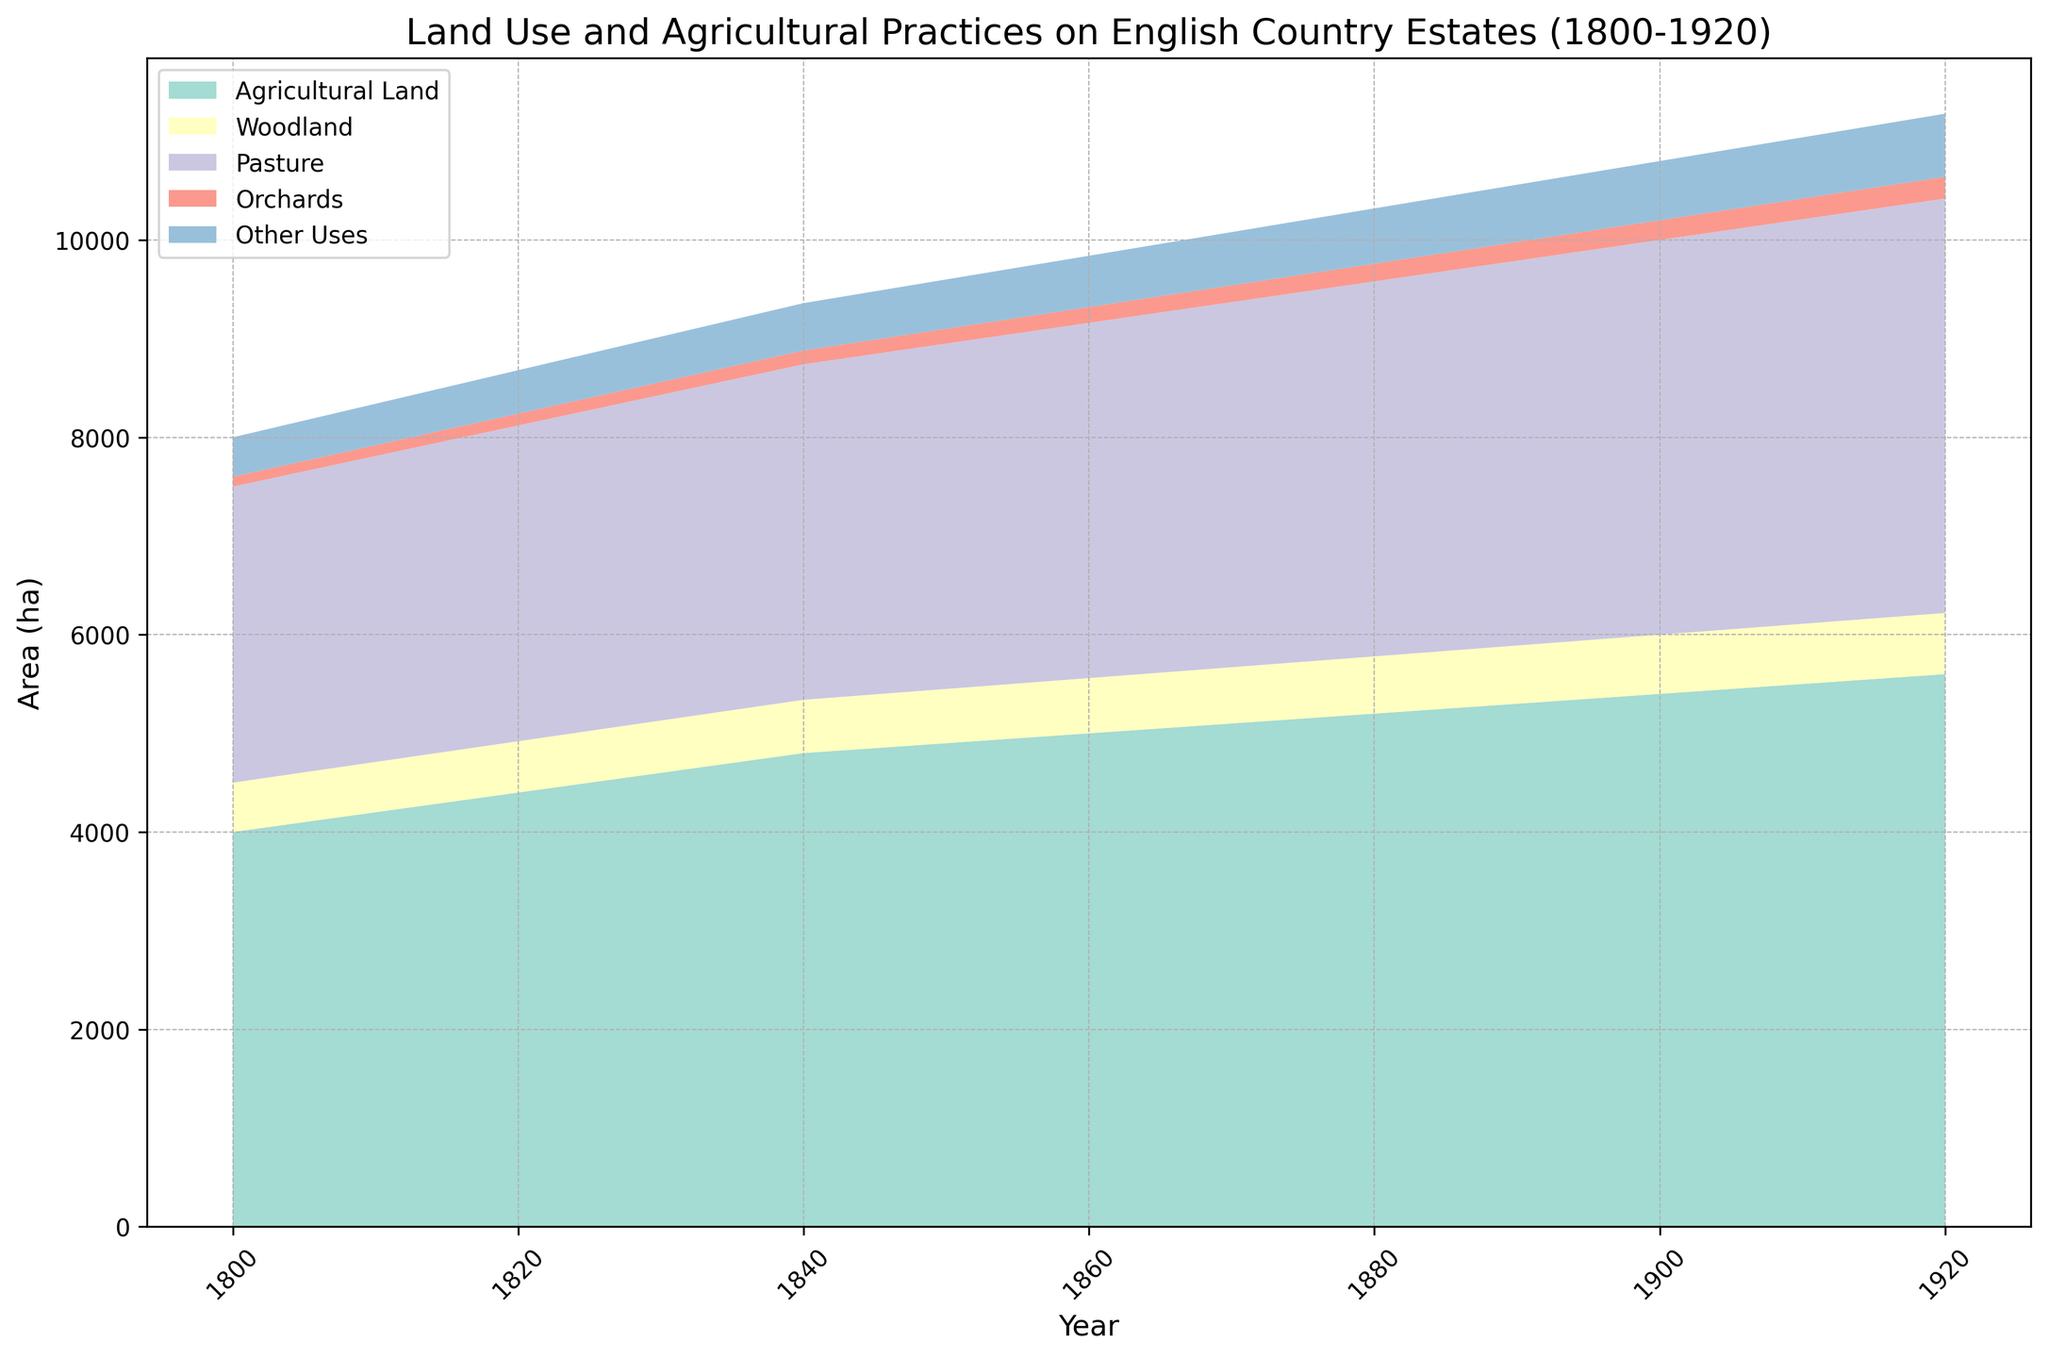How did the area of agricultural land change from 1800 to 1920? To determine how the area of agricultural land changed, look at the starting value in 1800 and the end value in 1920. The value increased from 4000 hectares in 1800 to 5600 hectares in 1920. This represents an increase of 1600 hectares over the period.
Answer: Increased by 1600 hectares Which land use had the smallest area in 1900? In the year 1900, to find the land use with the smallest area, compare the values of agricultural land, woodland, pasture, orchards, and other uses. Orchards had the smallest area at 200 hectares.
Answer: Orchards By how much did the pasture land area increase from 1800 to 1920? Look at the pasture land area in 1800 and 1920. It increased from 3000 hectares in 1800 to 4200 hectares in 1920. The increase is calculated as 4200 - 3000 = 1200 hectares.
Answer: 1200 hectares What is the total area of all land uses combined in 1850? Add the values for agricultural land, woodland, pasture, orchards, and other uses for 1850. The total area is 4900 + 550 + 3500 + 150 + 500 = 9600 hectares.
Answer: 9600 hectares Did woodland area ever decline between 1800 and 1920? Scan through the data for woodland areas to see if any years show a decrease. The woodland area increases monotonously from 500 hectares in 1800 to 620 hectares in 1920, with no decline.
Answer: No In which decade did the area of agricultural land see the highest increase? Calculate the increase in agricultural land for each decade: 1800-1810 (4200-4000=200 hectares), 1810-1820 (4400-4200=200 hectares), 1820-1830 (4600-4400=200 hectares), and continue this for each decade. The increases are constant at 200 hectares per decade.
Answer: 1800s to 1810s (or each decade equally) Which land use had the highest area in 1920? Look at the areas of all land uses in 1920. Agricultural land had the highest area at 5600 hectares.
Answer: Agricultural Land How does the rate of increase of orchard land compare to agricultural land? Compare the changes of orchard land and agricultural land from 1800 to 1920. Orchard land increased from 100 to 220 hectares (120 hectares increase), while agricultural land increased from 4000 to 5600 hectares (1600 hectares increase). The rate of increase for orchard land is slower.
Answer: Agricultural land increased faster Was there any decade where orchard area remained the same? Compare year-to-year changes in the orchard area. Each decade from 1800 to 1920 shows an increase, so there is no decade where the orchard area remained the same.
Answer: No Which color represents pasture land in the chart? By referring to the color legend in the chart, the pasture land is represented by a purple color.
Answer: Purple 